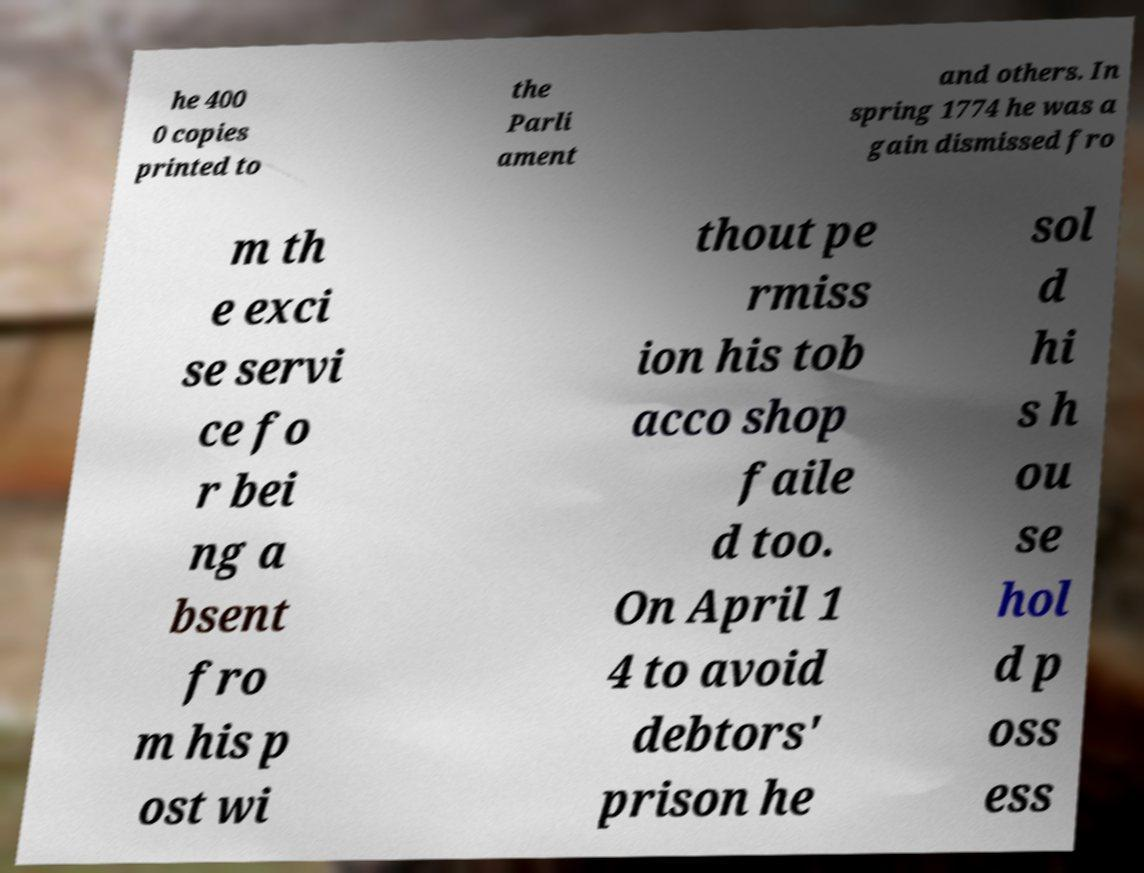There's text embedded in this image that I need extracted. Can you transcribe it verbatim? he 400 0 copies printed to the Parli ament and others. In spring 1774 he was a gain dismissed fro m th e exci se servi ce fo r bei ng a bsent fro m his p ost wi thout pe rmiss ion his tob acco shop faile d too. On April 1 4 to avoid debtors' prison he sol d hi s h ou se hol d p oss ess 